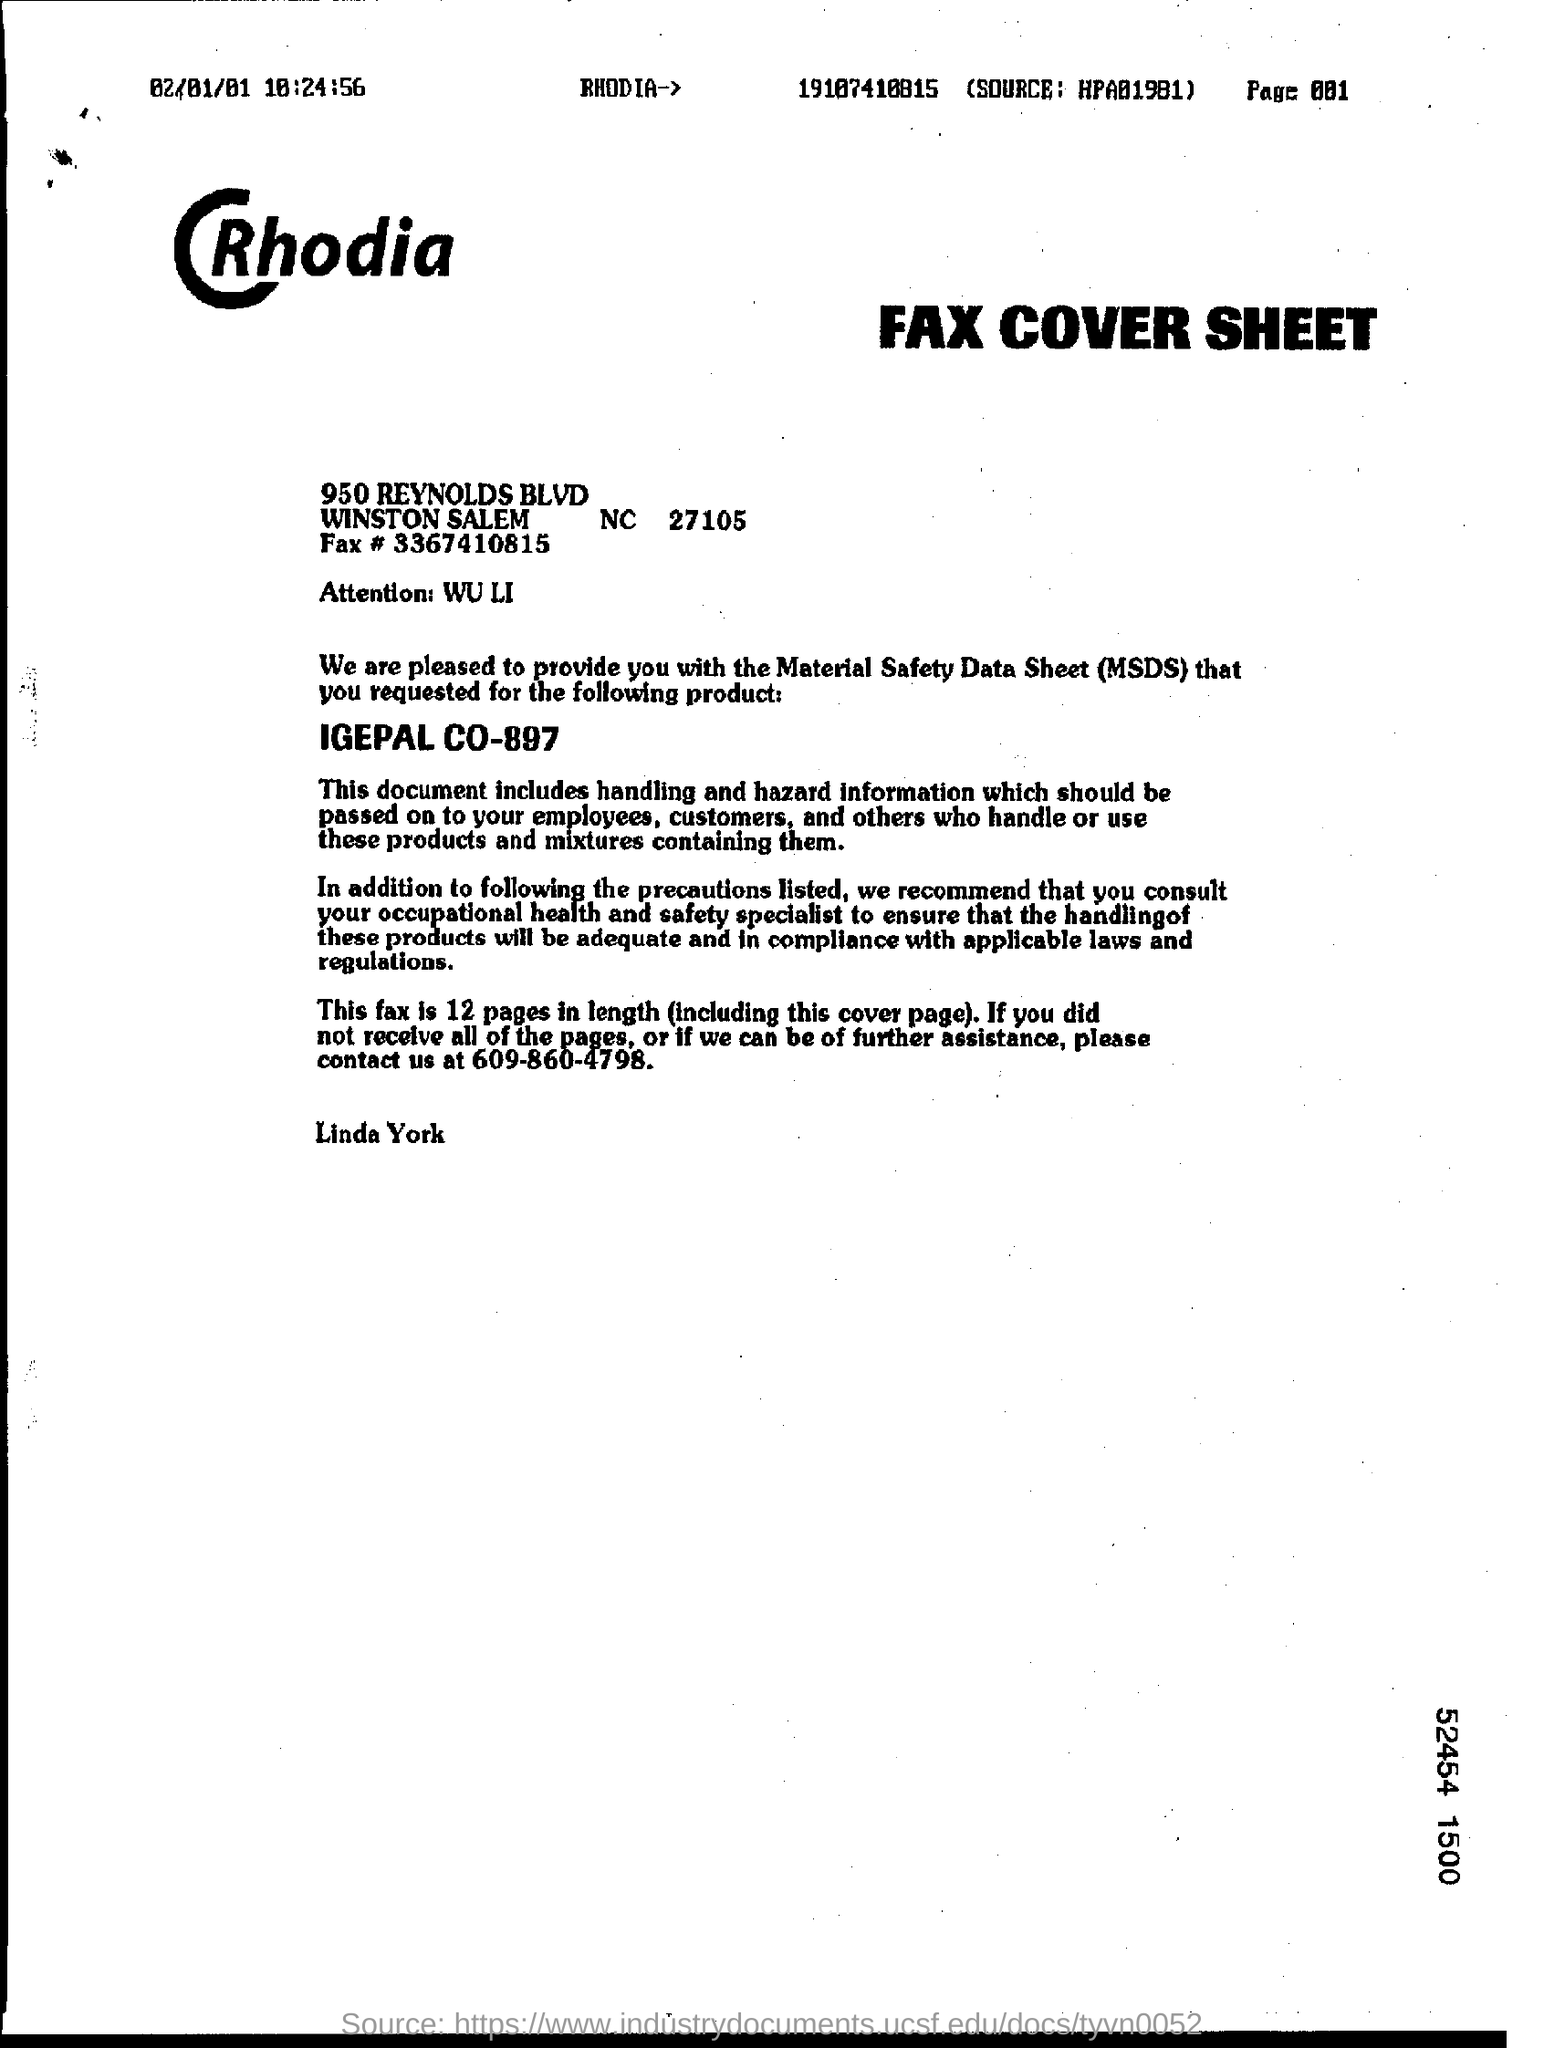What is the full form of msds ?
Your response must be concise. Material safety data sheet. How many pages are there including cover page ?
Your answer should be compact. 12. What is the contact number given for further assistance ?
Make the answer very short. 609-860-4798. What is the date mentioned in the page ?
Offer a very short reply. 02/01/01. 